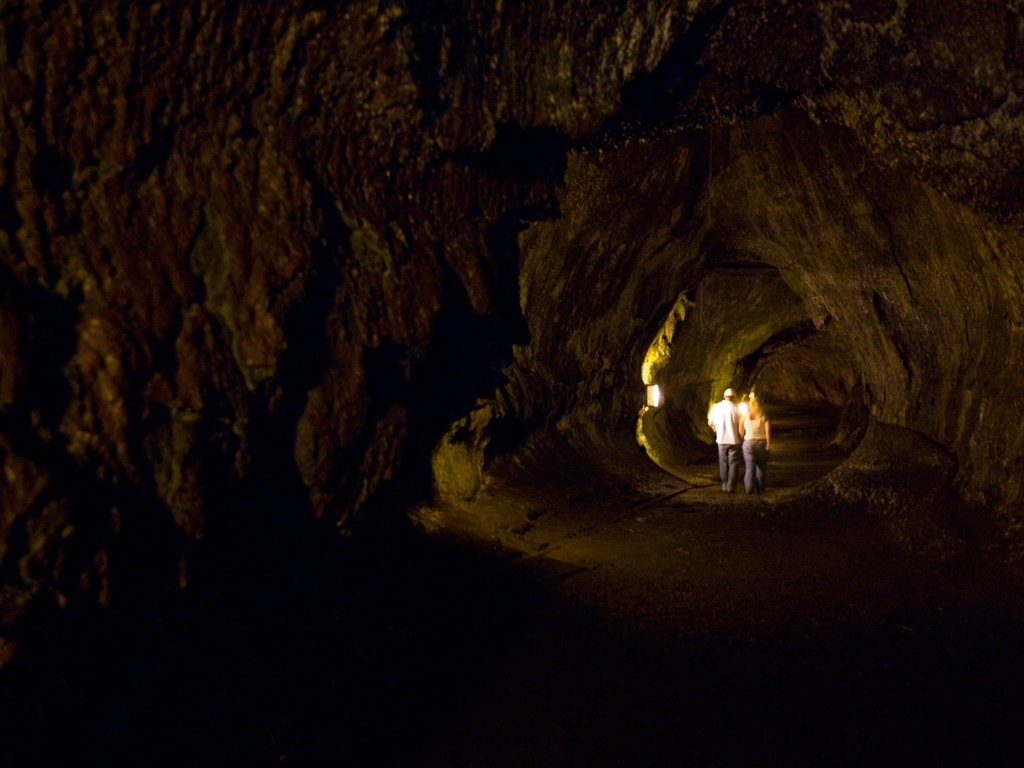Is the lighting in the image dim? Based on the image, it is evident that the lighting condition is indeed dim, with only specific areas being illuminated, possibly by artificial light sources that the individuals in the scene are carrying. The majority of the surroundings are engulfed in shadows, adding to the overall dim ambiance. 